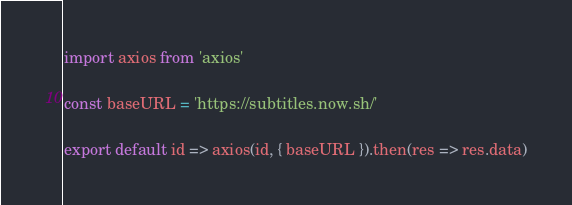<code> <loc_0><loc_0><loc_500><loc_500><_JavaScript_>import axios from 'axios'

const baseURL = 'https://subtitles.now.sh/'

export default id => axios(id, { baseURL }).then(res => res.data)
</code> 